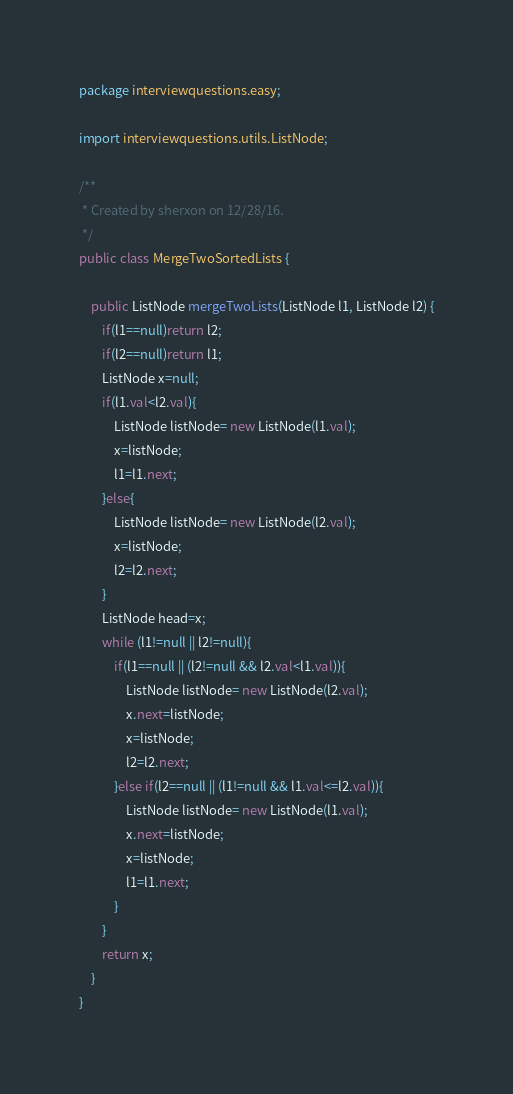<code> <loc_0><loc_0><loc_500><loc_500><_Java_>package interviewquestions.easy;

import interviewquestions.utils.ListNode;

/**
 * Created by sherxon on 12/28/16.
 */
public class MergeTwoSortedLists {

    public ListNode mergeTwoLists(ListNode l1, ListNode l2) {
        if(l1==null)return l2;
        if(l2==null)return l1;
        ListNode x=null;
        if(l1.val<l2.val){
            ListNode listNode= new ListNode(l1.val);
            x=listNode;
            l1=l1.next;
        }else{
            ListNode listNode= new ListNode(l2.val);
            x=listNode;
            l2=l2.next;
        }
        ListNode head=x;
        while (l1!=null || l2!=null){
            if(l1==null || (l2!=null && l2.val<l1.val)){
                ListNode listNode= new ListNode(l2.val);
                x.next=listNode;
                x=listNode;
                l2=l2.next;
            }else if(l2==null || (l1!=null && l1.val<=l2.val)){
                ListNode listNode= new ListNode(l1.val);
                x.next=listNode;
                x=listNode;
                l1=l1.next;
            }
        }
        return x;
    }
}
</code> 